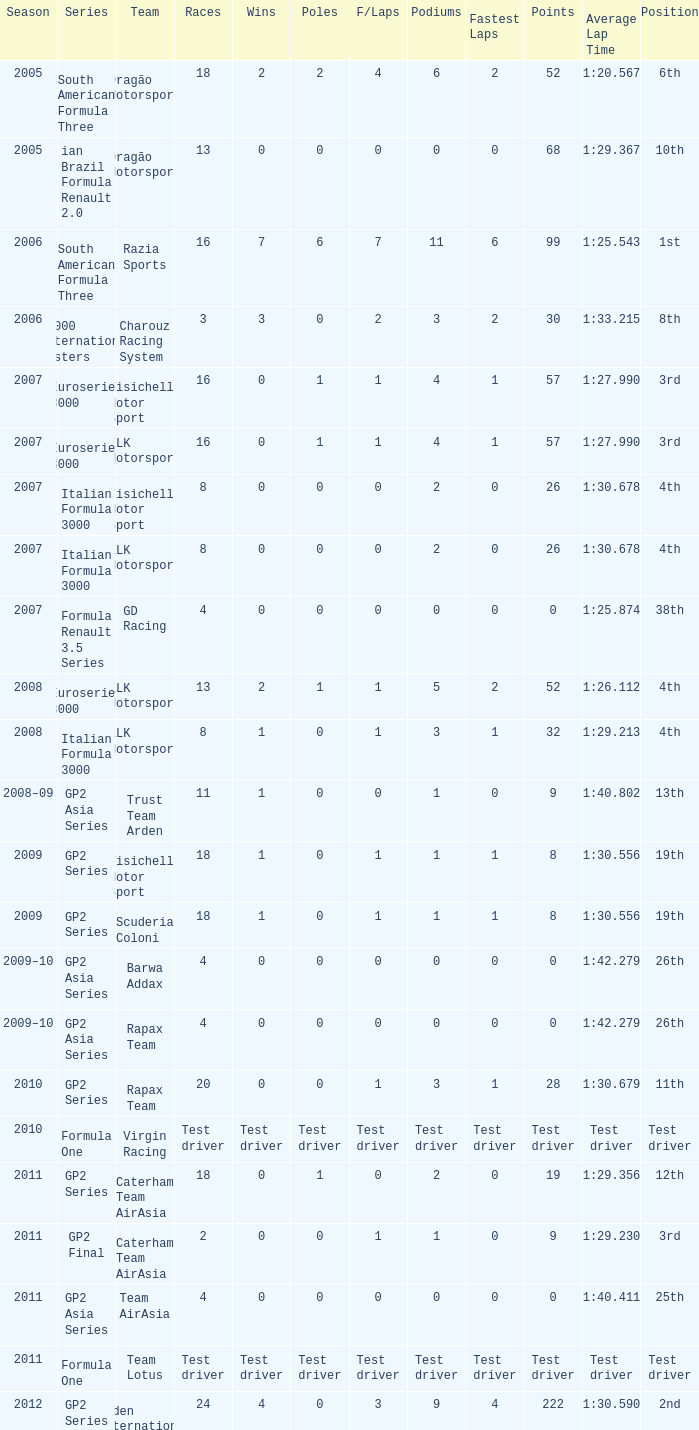How many races did he do in the year he had 8 points? 18, 18. 